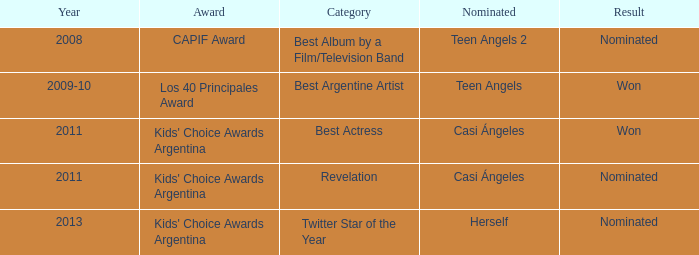What was the nomination year for teen angels 2? 2008.0. 